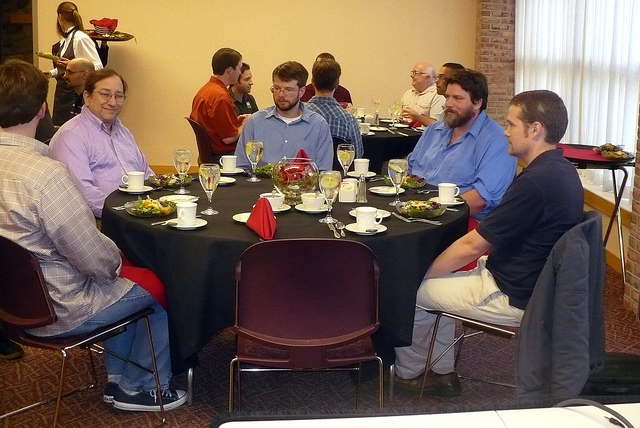What appears to be the occasion for this gathering? Based on the setup with dining tables, shared meals, and casual attire, it looks like a social or professional gathering, possibly a luncheon or a small banquet function. 